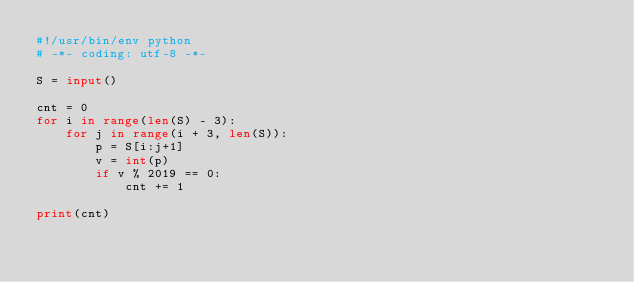<code> <loc_0><loc_0><loc_500><loc_500><_Python_>#!/usr/bin/env python
# -*- coding: utf-8 -*-

S = input()

cnt = 0
for i in range(len(S) - 3):
    for j in range(i + 3, len(S)):
        p = S[i:j+1]
        v = int(p)
        if v % 2019 == 0:
            cnt += 1

print(cnt)
</code> 